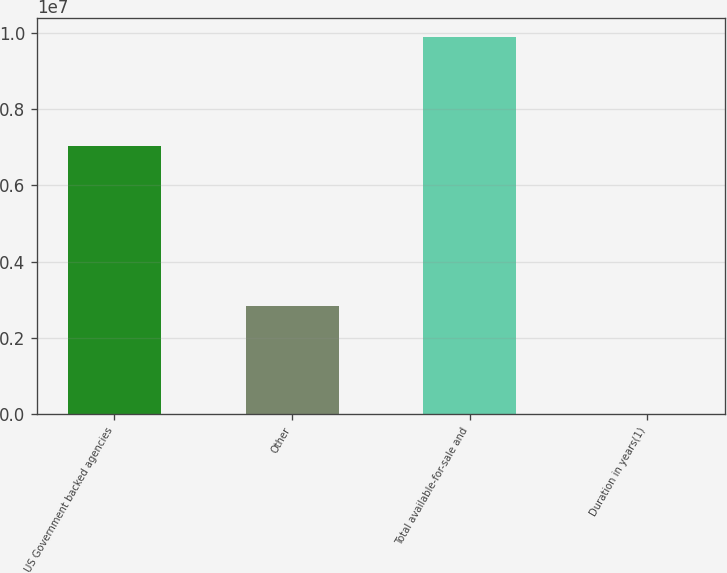Convert chart. <chart><loc_0><loc_0><loc_500><loc_500><bar_chart><fcel>US Government backed agencies<fcel>Other<fcel>Total available-for-sale and<fcel>Duration in years(1)<nl><fcel>7.04803e+06<fcel>2.84722e+06<fcel>9.89524e+06<fcel>3<nl></chart> 